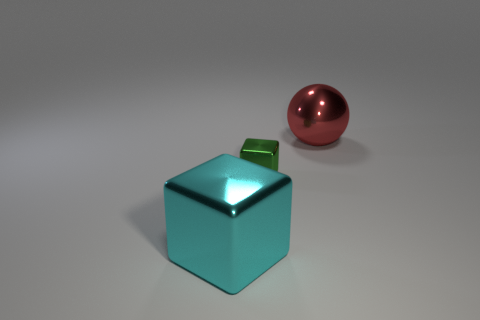Subtract 2 cubes. How many cubes are left? 0 Add 2 big cyan blocks. How many objects exist? 5 Subtract all cyan blocks. How many blocks are left? 1 Subtract all yellow cubes. Subtract all gray cylinders. How many cubes are left? 2 Subtract all yellow blocks. How many brown balls are left? 0 Subtract all yellow metallic cylinders. Subtract all balls. How many objects are left? 2 Add 1 small shiny blocks. How many small shiny blocks are left? 2 Add 2 large red rubber cubes. How many large red rubber cubes exist? 2 Subtract 0 blue cylinders. How many objects are left? 3 Subtract all spheres. How many objects are left? 2 